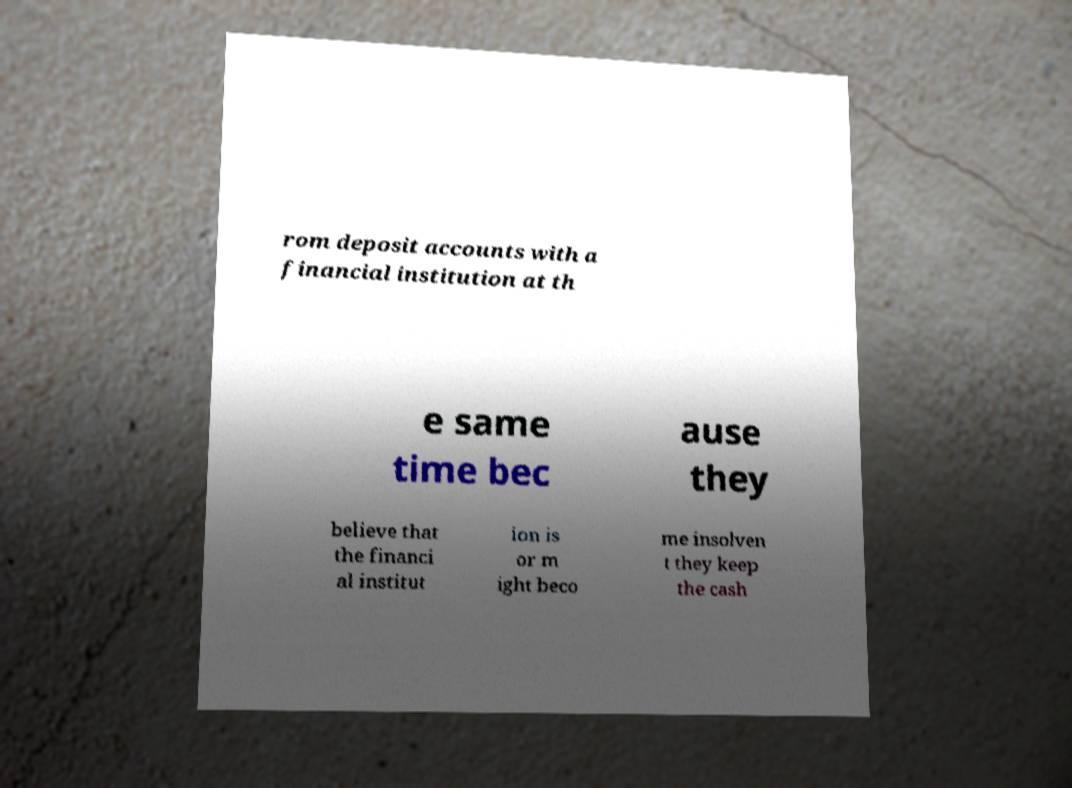Please read and relay the text visible in this image. What does it say? rom deposit accounts with a financial institution at th e same time bec ause they believe that the financi al institut ion is or m ight beco me insolven t they keep the cash 